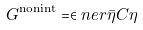<formula> <loc_0><loc_0><loc_500><loc_500>\ G ^ { \text {nonint} } = \in n e r { \bar { \eta } } { C \eta }</formula> 